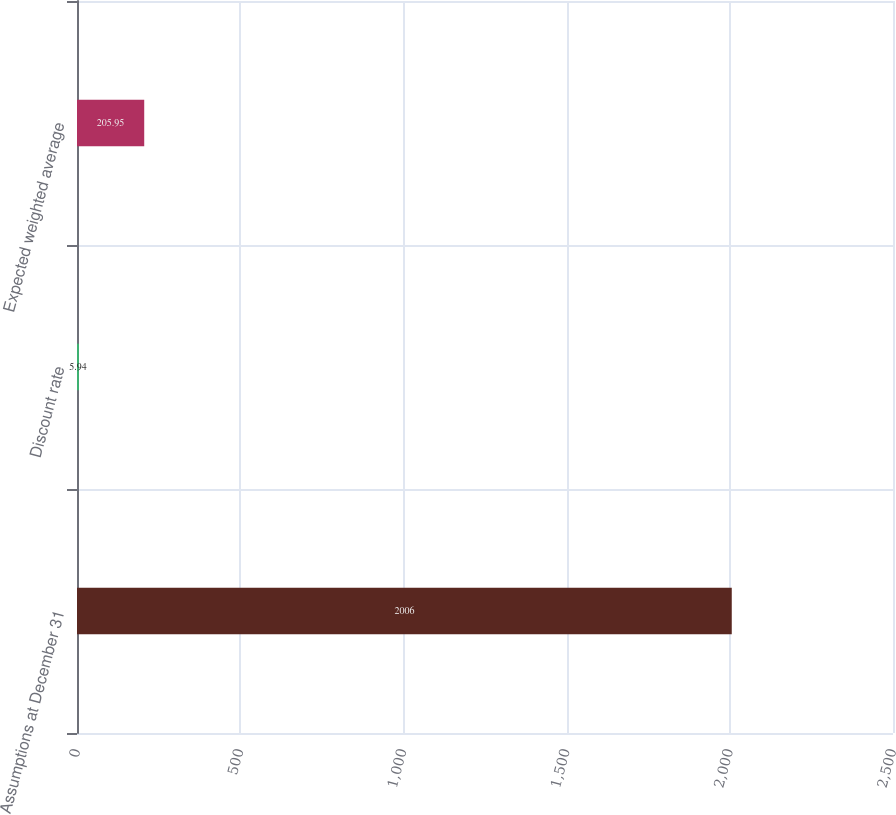Convert chart. <chart><loc_0><loc_0><loc_500><loc_500><bar_chart><fcel>Assumptions at December 31<fcel>Discount rate<fcel>Expected weighted average<nl><fcel>2006<fcel>5.94<fcel>205.95<nl></chart> 